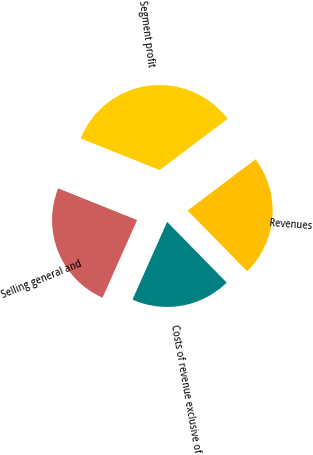Convert chart to OTSL. <chart><loc_0><loc_0><loc_500><loc_500><pie_chart><fcel>Revenues<fcel>Costs of revenue exclusive of<fcel>Selling general and<fcel>Segment profit<nl><fcel>22.94%<fcel>19.02%<fcel>24.4%<fcel>33.65%<nl></chart> 